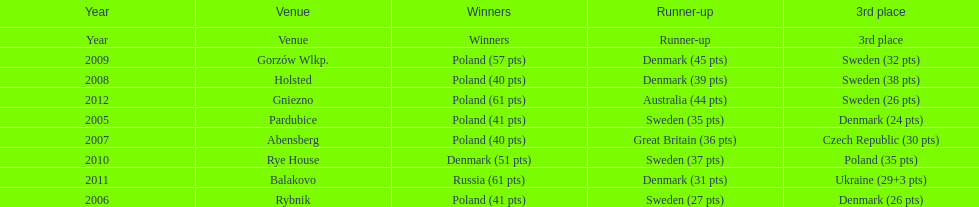After their first place win in 2009, how did poland place the next year at the speedway junior world championship? 3rd place. 